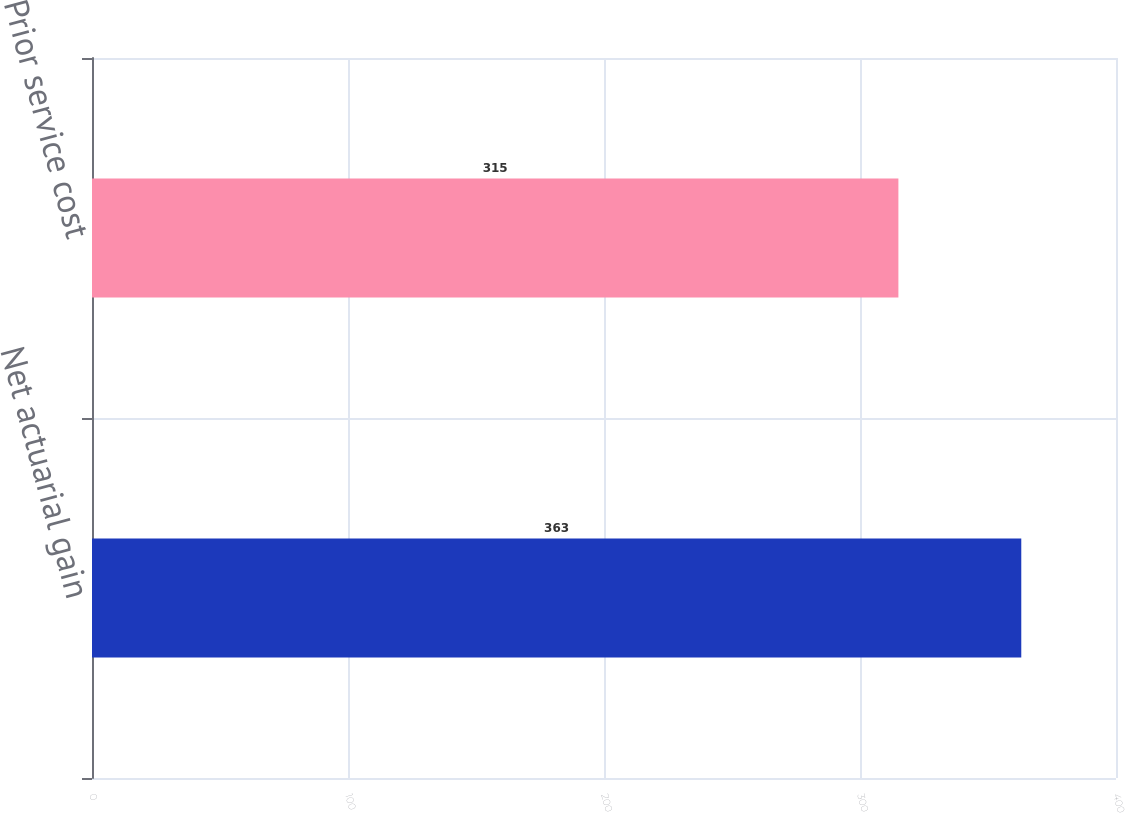Convert chart to OTSL. <chart><loc_0><loc_0><loc_500><loc_500><bar_chart><fcel>Net actuarial gain<fcel>Prior service cost<nl><fcel>363<fcel>315<nl></chart> 